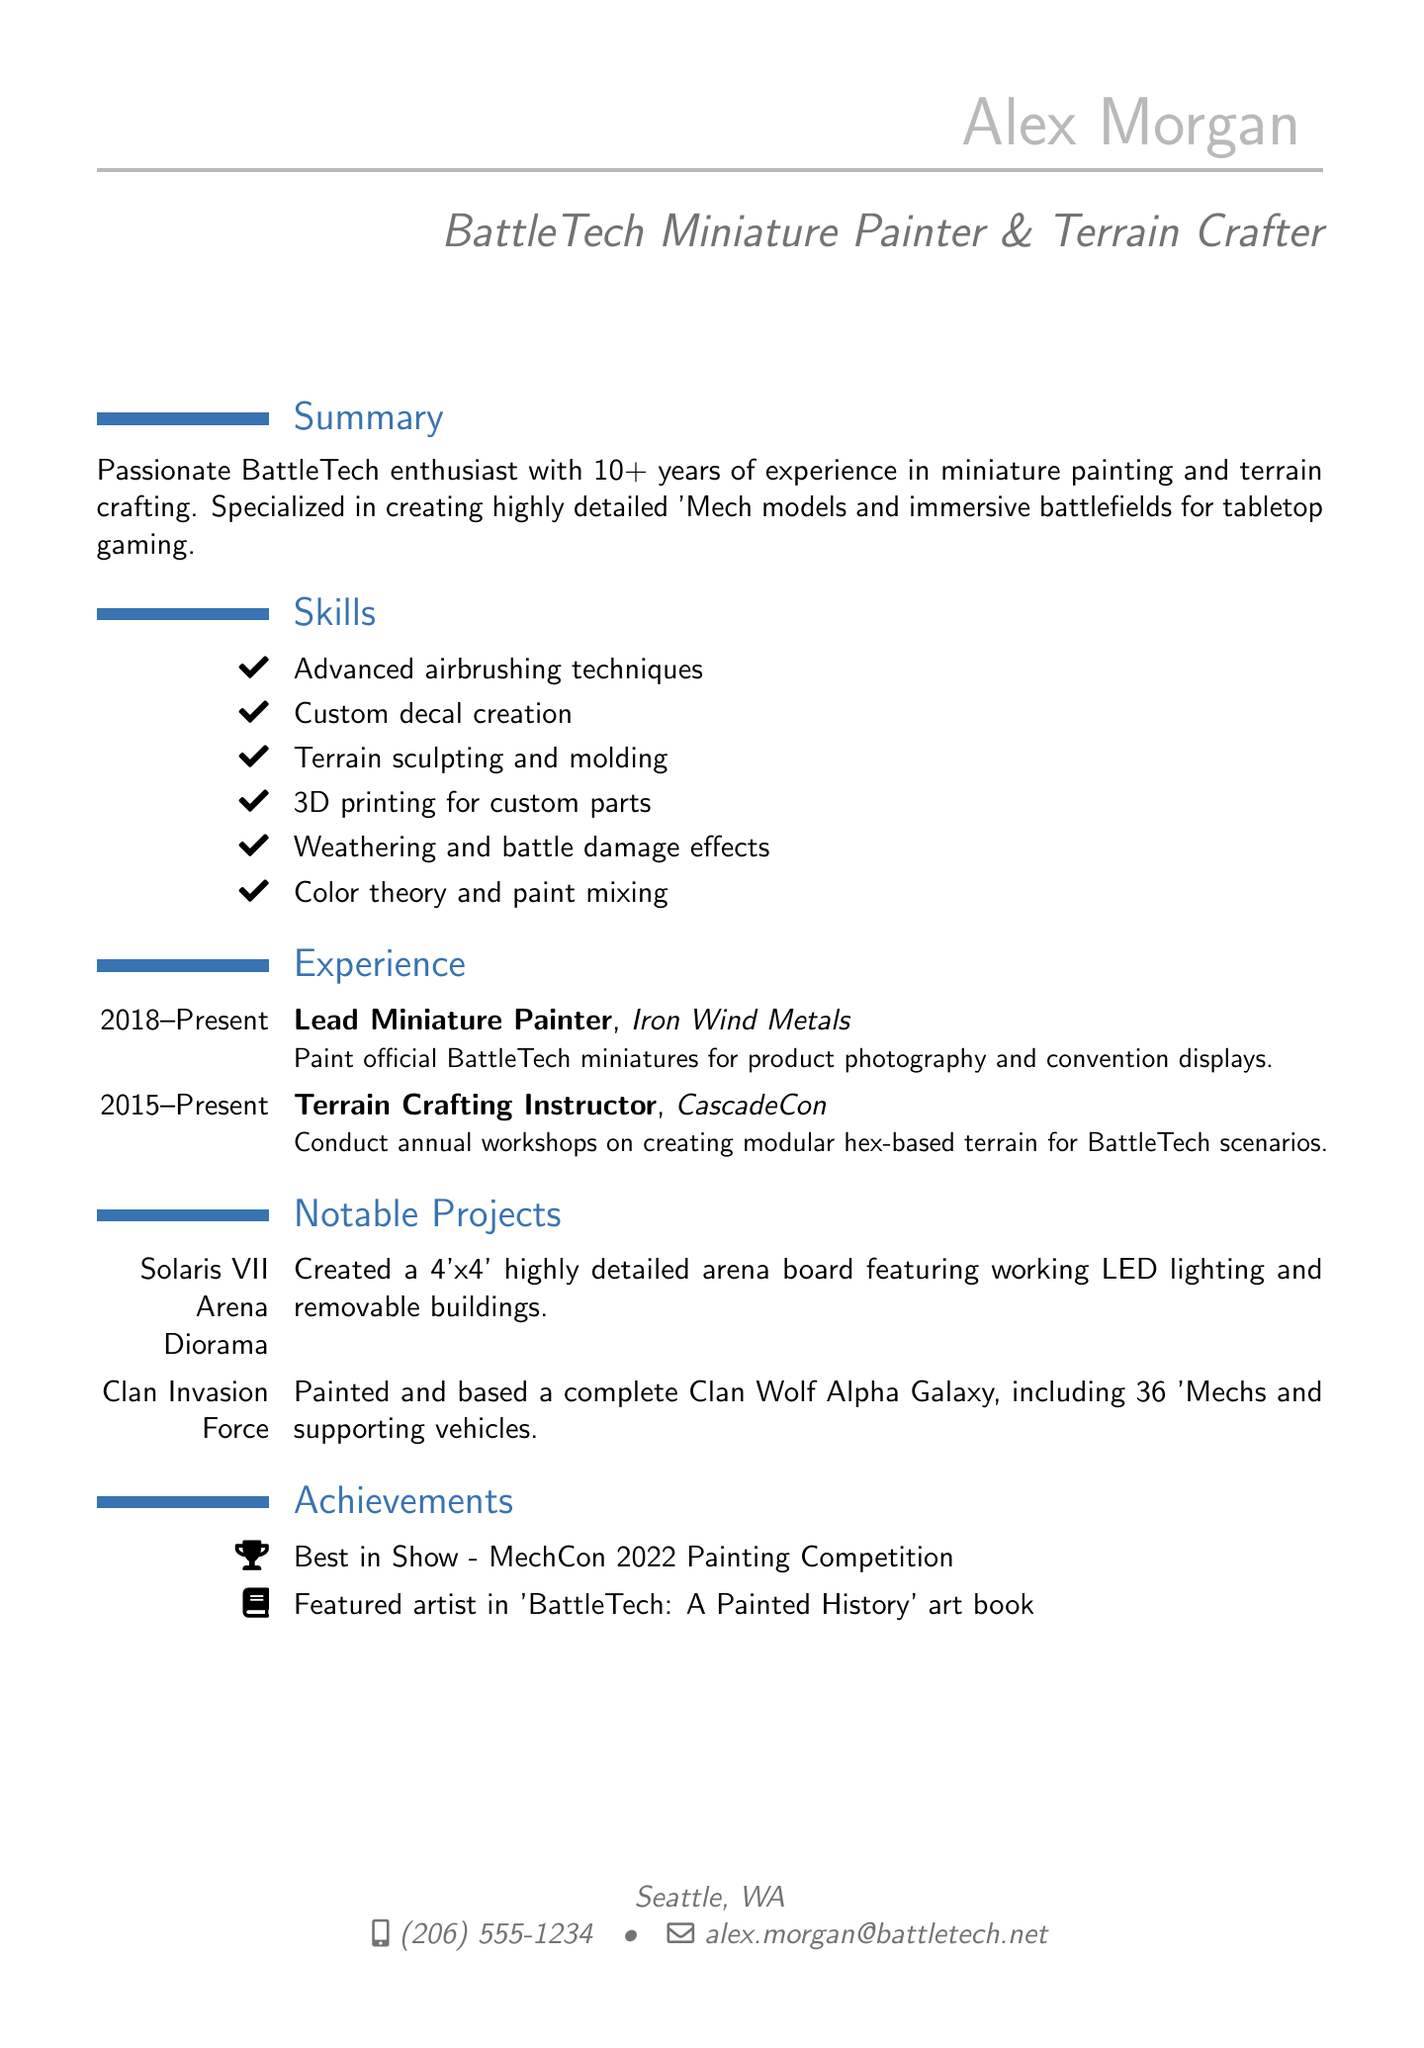What is the name of the individual? The document provides the name of the individual at the start, which is Alex Morgan.
Answer: Alex Morgan What is the location listed in the document? The location is mentioned in the personal information section as where Alex Morgan resides, which is Seattle, WA.
Answer: Seattle, WA How many years of experience does Alex have? The summary states that Alex has more than 10 years of experience in the field.
Answer: 10+ Which company does Alex work for as a Lead Miniature Painter? The company for which Alex works is specified in the experience section as Iron Wind Metals.
Answer: Iron Wind Metals What notable project features working LED lighting? The notable project that includes working LED lighting is specified in the document as the Solaris VII Arena Diorama.
Answer: Solaris VII Arena Diorama How many 'Mechs are included in the Clan Invasion Force project? The document details that the Clan Invasion Force project includes 36 'Mechs.
Answer: 36 What award did Alex win in 2022? The achievements section notes that Alex won the Best in Show at the MechCon 2022 Painting Competition.
Answer: Best in Show What role does Alex have at CascadeCon? The document describes Alex's role at CascadeCon as a Terrain Crafting Instructor.
Answer: Terrain Crafting Instructor Which skill involves customizing decals? The skills section specifies that custom decal creation is one of the skills listed.
Answer: Custom decal creation 